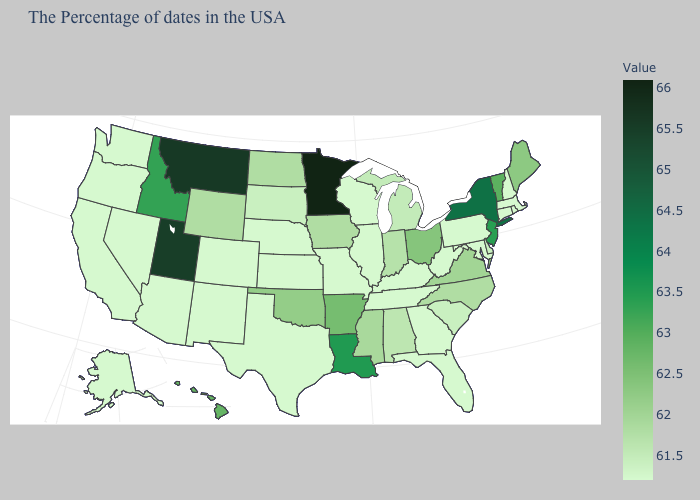Among the states that border Delaware , does New Jersey have the highest value?
Be succinct. Yes. Among the states that border Delaware , does New Jersey have the highest value?
Be succinct. Yes. Does Oregon have the lowest value in the West?
Answer briefly. Yes. Which states have the lowest value in the South?
Write a very short answer. Maryland, West Virginia, Florida, Georgia, Kentucky, Tennessee, Texas. Which states have the lowest value in the USA?
Write a very short answer. Massachusetts, Rhode Island, New Hampshire, Connecticut, Maryland, Pennsylvania, West Virginia, Florida, Georgia, Kentucky, Tennessee, Wisconsin, Illinois, Missouri, Kansas, Nebraska, Texas, Colorado, New Mexico, Arizona, Nevada, California, Washington, Oregon, Alaska. 